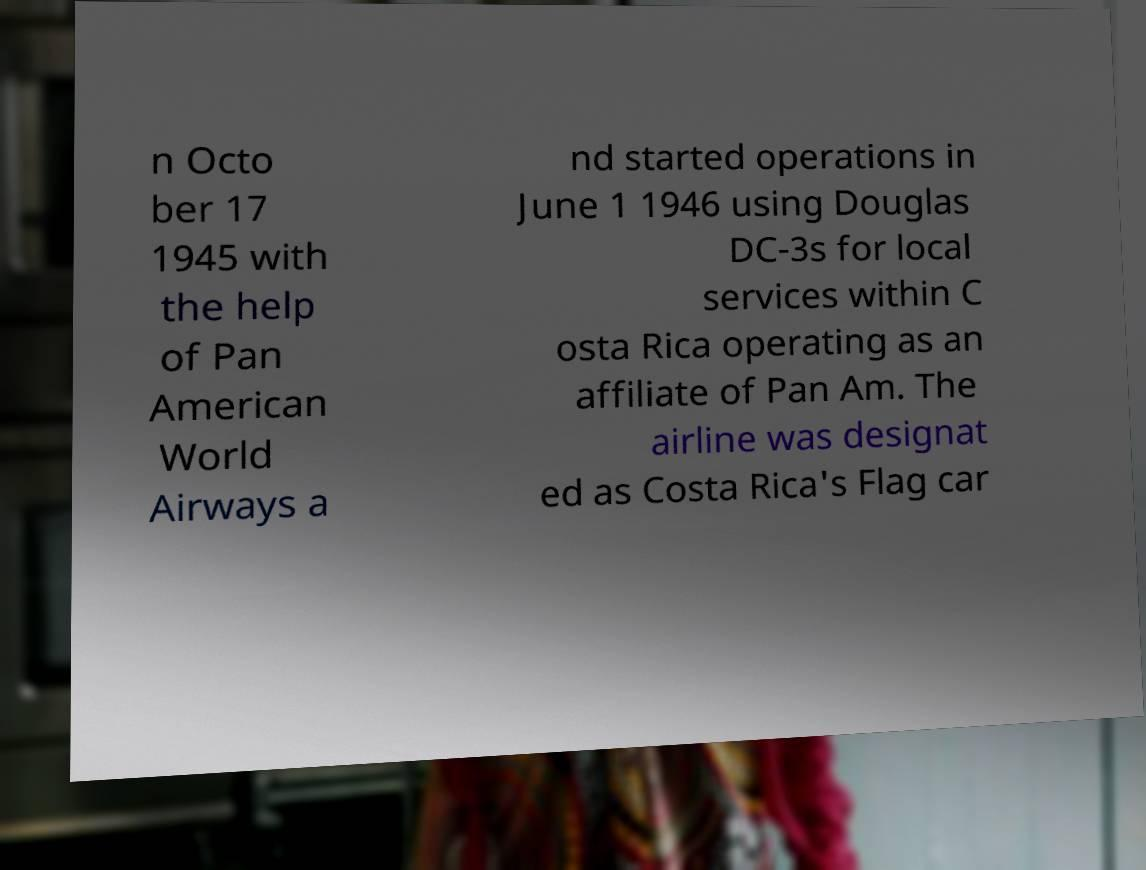What messages or text are displayed in this image? I need them in a readable, typed format. n Octo ber 17 1945 with the help of Pan American World Airways a nd started operations in June 1 1946 using Douglas DC-3s for local services within C osta Rica operating as an affiliate of Pan Am. The airline was designat ed as Costa Rica's Flag car 